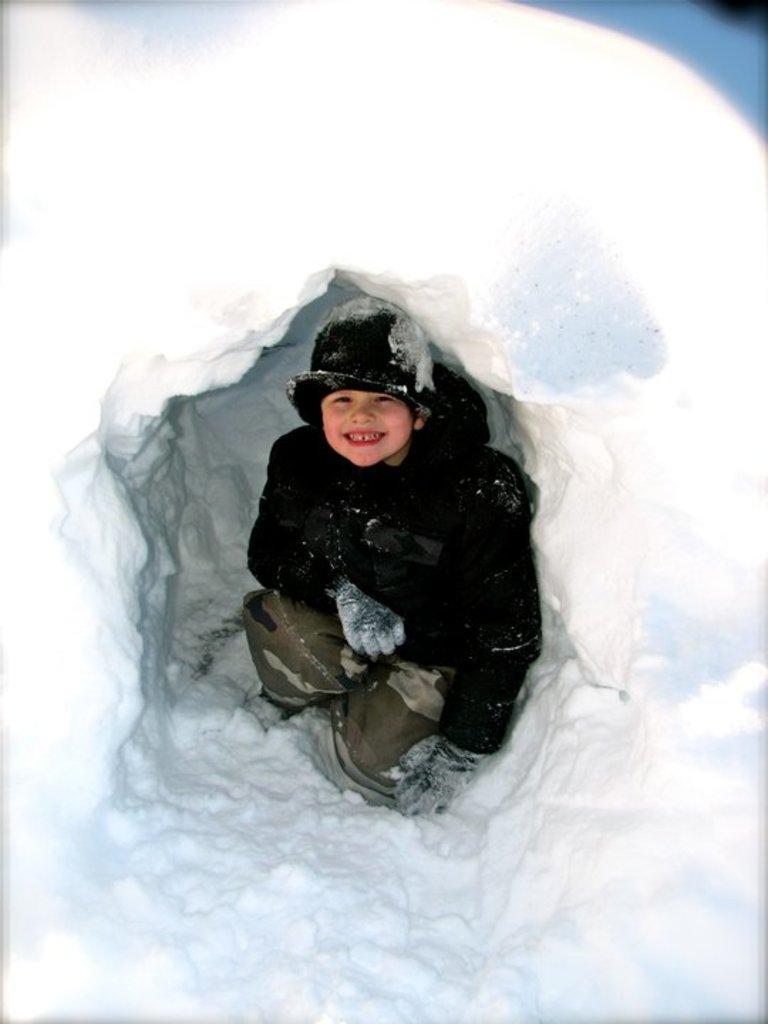Describe this image in one or two sentences. In this image I can see a boy visible under snow tent. 